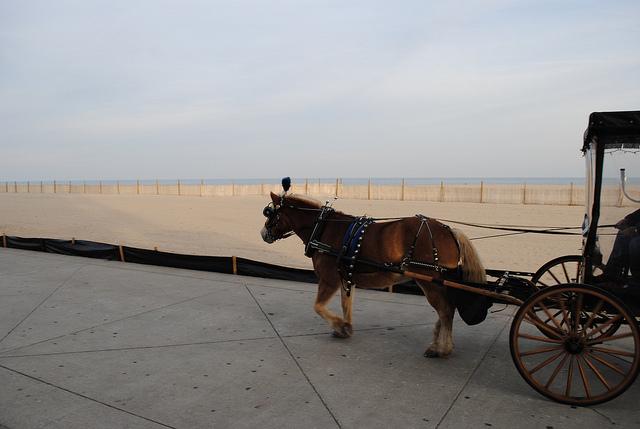How many horses?
Be succinct. 1. How many cars are here?
Write a very short answer. 0. Is the horse walking on pavement?
Answer briefly. Yes. What is the horse pulling?
Answer briefly. Carriage. 